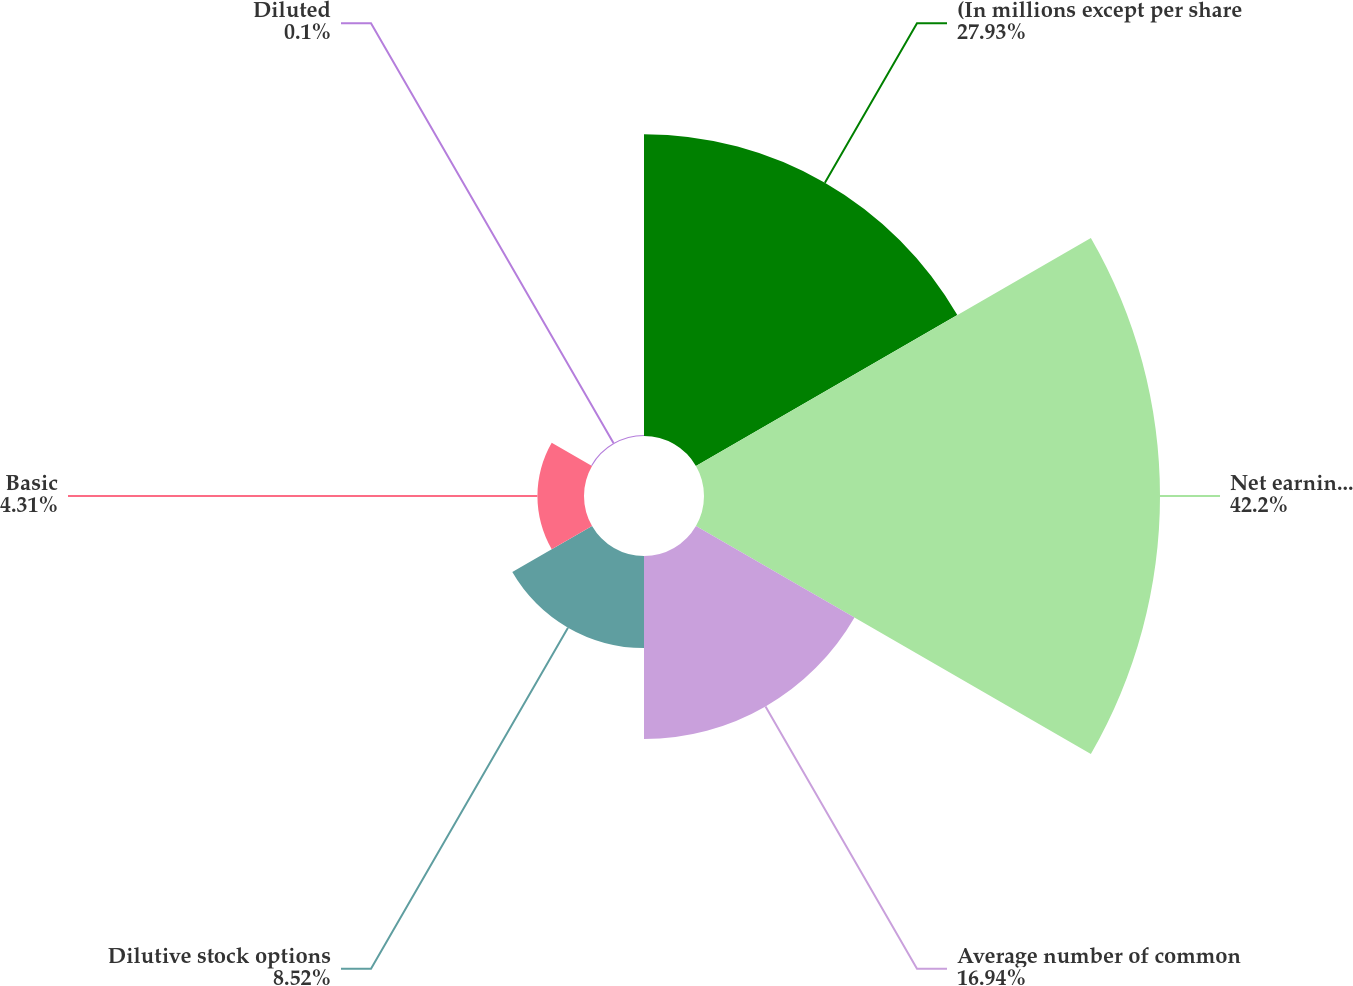Convert chart. <chart><loc_0><loc_0><loc_500><loc_500><pie_chart><fcel>(In millions except per share<fcel>Net earnings for basic and<fcel>Average number of common<fcel>Dilutive stock options<fcel>Basic<fcel>Diluted<nl><fcel>27.93%<fcel>42.2%<fcel>16.94%<fcel>8.52%<fcel>4.31%<fcel>0.1%<nl></chart> 